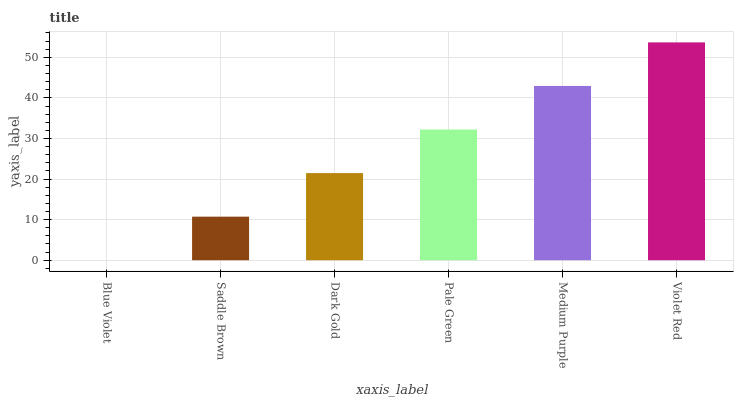Is Blue Violet the minimum?
Answer yes or no. Yes. Is Violet Red the maximum?
Answer yes or no. Yes. Is Saddle Brown the minimum?
Answer yes or no. No. Is Saddle Brown the maximum?
Answer yes or no. No. Is Saddle Brown greater than Blue Violet?
Answer yes or no. Yes. Is Blue Violet less than Saddle Brown?
Answer yes or no. Yes. Is Blue Violet greater than Saddle Brown?
Answer yes or no. No. Is Saddle Brown less than Blue Violet?
Answer yes or no. No. Is Pale Green the high median?
Answer yes or no. Yes. Is Dark Gold the low median?
Answer yes or no. Yes. Is Medium Purple the high median?
Answer yes or no. No. Is Violet Red the low median?
Answer yes or no. No. 